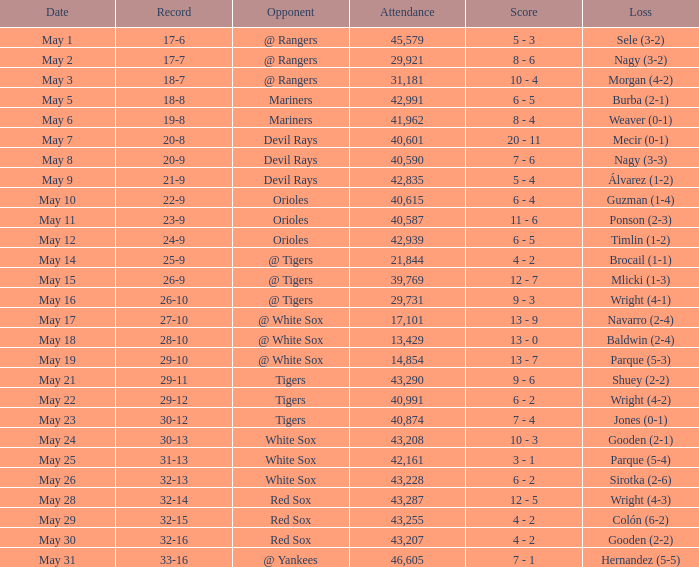What loss has 26-9 as a loss? Mlicki (1-3). 